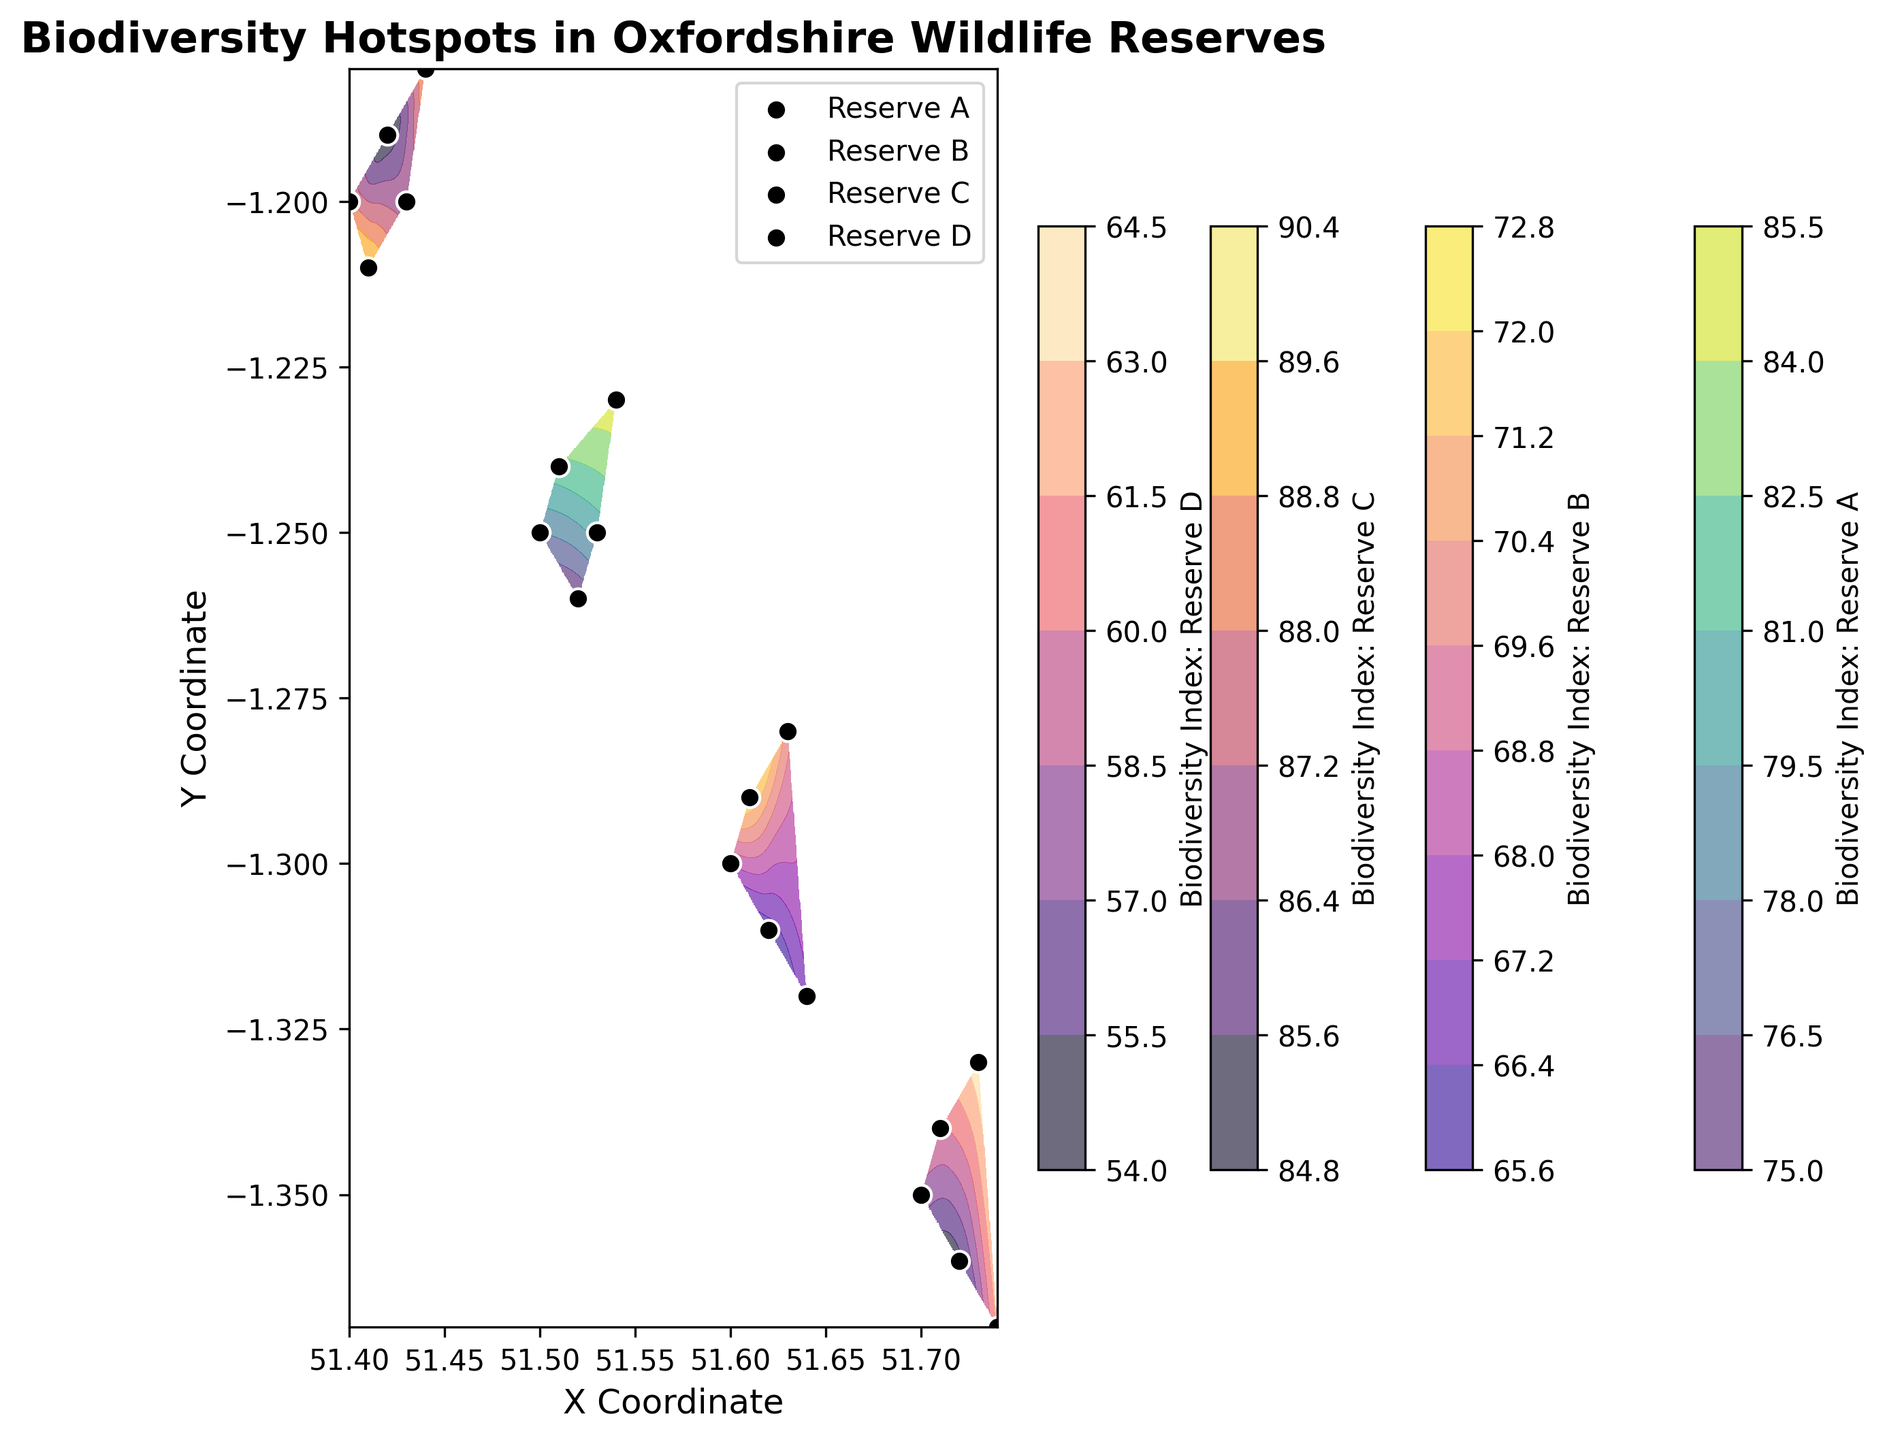What reserve has the highest biodiversity index according to the figure? To answer this question, look at the colorbar for each reserve and the contour levels on the map. The highest value on the contour map indicates the highest biodiversity index. Reserve C appears to reach values around 90 as indicated by the colorbar.
Answer: Reserve C Which reserve shows the largest area with high biodiversity index values? To answer this, observe the contour plot to see which reserve has the largest contiguous area with high biodiversity index values. Reserve C and Reserve A have noticeable large areas, but Reserve C has a broader spread of high values.
Answer: Reserve C How does the biodiversity index in Reserve B compare to Reserve D according to their highest values? Look at the colorbars for Reserve B and Reserve D on the figure. Reserve B reaches a maximum value around 72 while Reserve D reaches a maximum around 64. Reserve B has higher maximum values compared to Reserve D.
Answer: Reserve B has higher values What reserve shows the greatest range in biodiversity index values? Determine the range by looking at the highest and lowest contour values for each reserve. Reserve D has values ranging from 55 to 64, this span provides the largest range.
Answer: Reserve D Which reserve is located furthest to the south according to the figure? Inspect the figure's y-axis labels and look for the coordinates that place a reserve at the southernmost point. Reserve C, with points around y-coordinates of 51.4, is the furthest south.
Answer: Reserve C Compare the biodiversity indices of the southernmost points in Reserve A and Reserve D. Which is higher? Observe the color gradient for the southernmost data points of Reserve A and Reserve D. The southernmost point in Reserve A has an index around 75, while in Reserve D it’s about 55.
Answer: Reserve A is higher Which reserve has the most evenly distributed biodiversity index values? Even distribution is interpreted by observing the uniformity in the contour levels and colors. Reserve A shows a more even distribution compared to others where high and low indices are more mixed.
Answer: Reserve A What is the average biodiversity index of the highest points for each reserve? Identify the highest points in each reserve from the contour levels or color bars. Add these highest points: 85 (A) + 72 (B) + 90 (C) + 64 (D) and divide by 4. Average = (85 + 72 + 90 + 64) / 4 = 77.75.
Answer: 77.75 If you combine the areas of high biodiversity index for reserves A and C, do they cover more area than those of reserves B and D combined? Observe the sizes of high-biodiversity index regions. Reserve A and C combined visually cover more area than the combined high-biodiversity areas of B and D. This requires estimating and comparing contiguous regions of high contour lines.
Answer: Yes What are the coordinates of Reserve B's point with the highest biodiversity index? Locate the reserve's boundary and find the point close to the highest value on the contour plot. The coordinates closest to the highest index of 72 are around (51.61, -1.29).
Answer: (51.61, -1.29) 